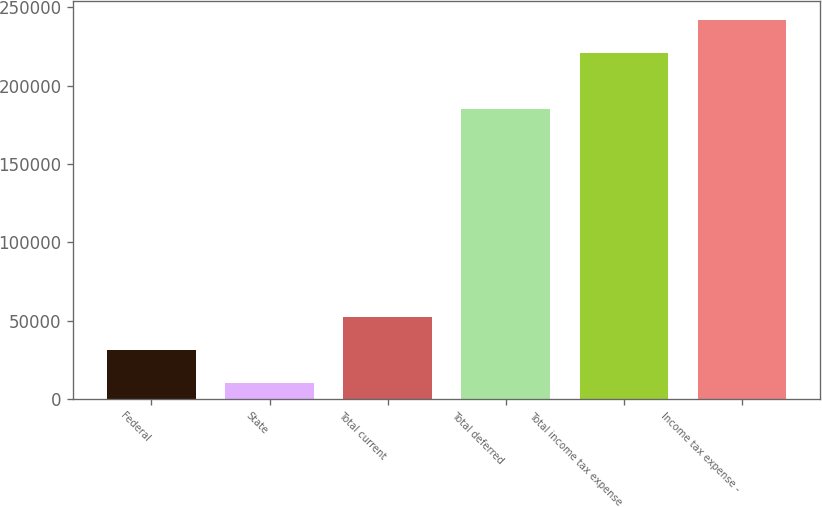<chart> <loc_0><loc_0><loc_500><loc_500><bar_chart><fcel>Federal<fcel>State<fcel>Total current<fcel>Total deferred<fcel>Total income tax expense<fcel>Income tax expense -<nl><fcel>31414.3<fcel>10382<fcel>52446.6<fcel>185269<fcel>220705<fcel>241737<nl></chart> 